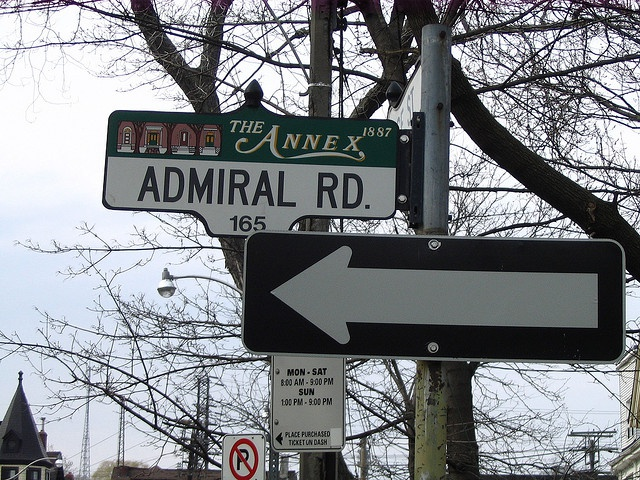Describe the objects in this image and their specific colors. I can see various objects in this image with different colors. 